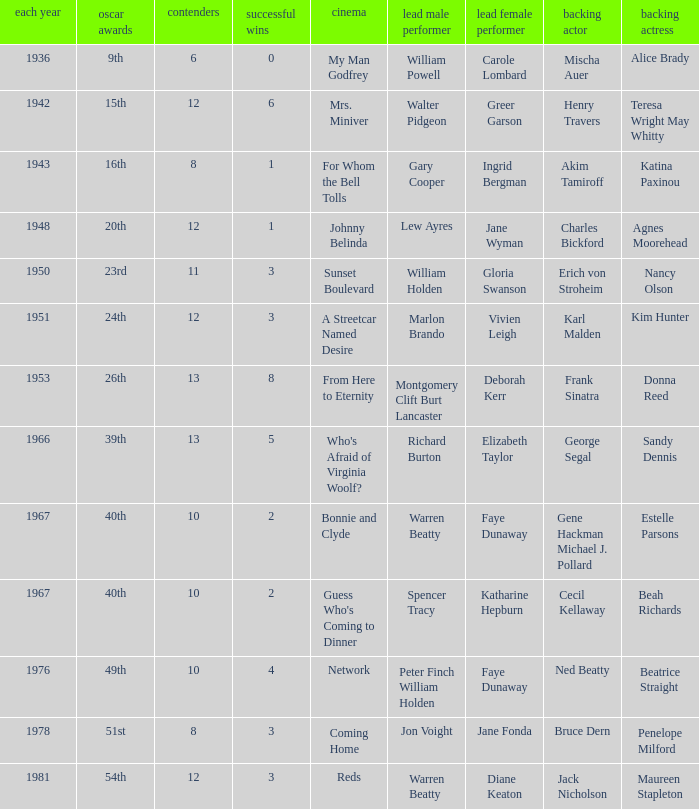Who was the supporting actress in 1943? Katina Paxinou. Parse the full table. {'header': ['each year', 'oscar awards', 'contenders', 'successful wins', 'cinema', 'lead male performer', 'lead female performer', 'backing actor', 'backing actress'], 'rows': [['1936', '9th', '6', '0', 'My Man Godfrey', 'William Powell', 'Carole Lombard', 'Mischa Auer', 'Alice Brady'], ['1942', '15th', '12', '6', 'Mrs. Miniver', 'Walter Pidgeon', 'Greer Garson', 'Henry Travers', 'Teresa Wright May Whitty'], ['1943', '16th', '8', '1', 'For Whom the Bell Tolls', 'Gary Cooper', 'Ingrid Bergman', 'Akim Tamiroff', 'Katina Paxinou'], ['1948', '20th', '12', '1', 'Johnny Belinda', 'Lew Ayres', 'Jane Wyman', 'Charles Bickford', 'Agnes Moorehead'], ['1950', '23rd', '11', '3', 'Sunset Boulevard', 'William Holden', 'Gloria Swanson', 'Erich von Stroheim', 'Nancy Olson'], ['1951', '24th', '12', '3', 'A Streetcar Named Desire', 'Marlon Brando', 'Vivien Leigh', 'Karl Malden', 'Kim Hunter'], ['1953', '26th', '13', '8', 'From Here to Eternity', 'Montgomery Clift Burt Lancaster', 'Deborah Kerr', 'Frank Sinatra', 'Donna Reed'], ['1966', '39th', '13', '5', "Who's Afraid of Virginia Woolf?", 'Richard Burton', 'Elizabeth Taylor', 'George Segal', 'Sandy Dennis'], ['1967', '40th', '10', '2', 'Bonnie and Clyde', 'Warren Beatty', 'Faye Dunaway', 'Gene Hackman Michael J. Pollard', 'Estelle Parsons'], ['1967', '40th', '10', '2', "Guess Who's Coming to Dinner", 'Spencer Tracy', 'Katharine Hepburn', 'Cecil Kellaway', 'Beah Richards'], ['1976', '49th', '10', '4', 'Network', 'Peter Finch William Holden', 'Faye Dunaway', 'Ned Beatty', 'Beatrice Straight'], ['1978', '51st', '8', '3', 'Coming Home', 'Jon Voight', 'Jane Fonda', 'Bruce Dern', 'Penelope Milford'], ['1981', '54th', '12', '3', 'Reds', 'Warren Beatty', 'Diane Keaton', 'Jack Nicholson', 'Maureen Stapleton']]} 